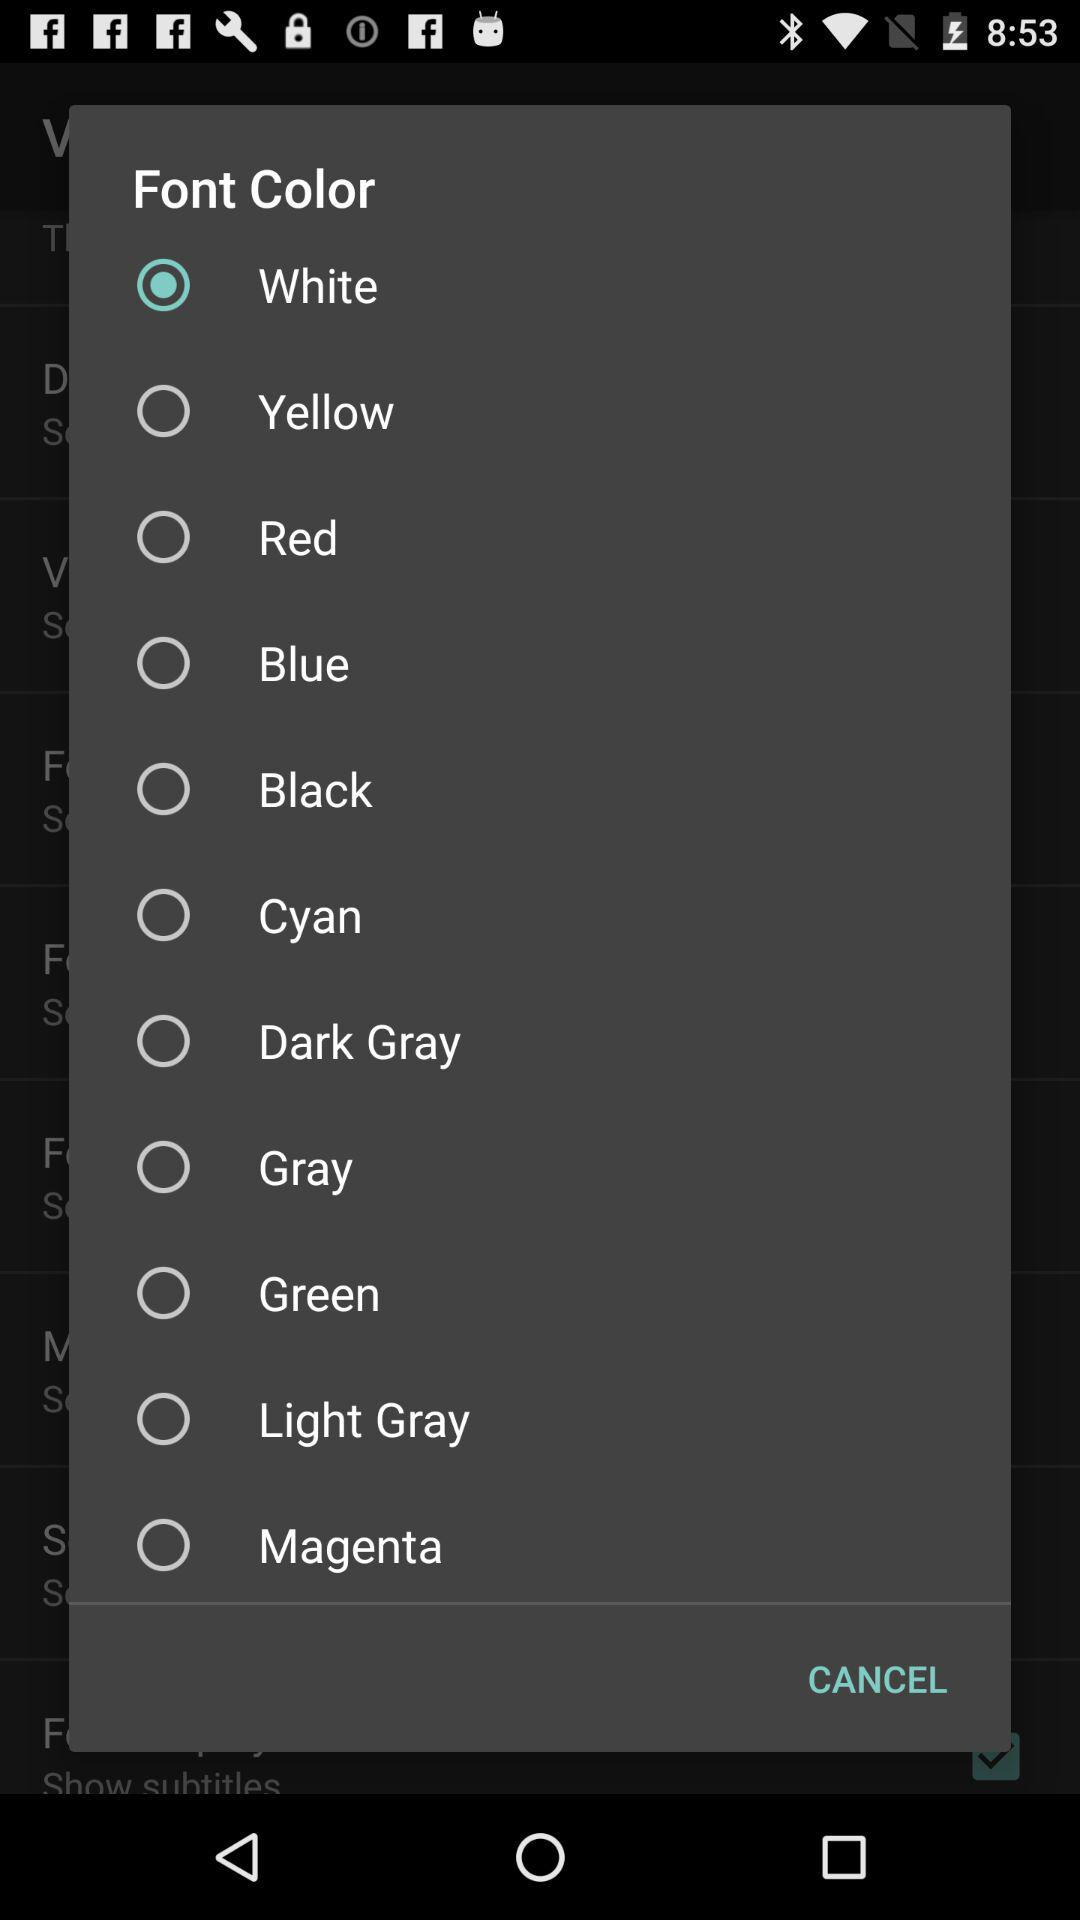What is the selected font color? The selected font color is white. 